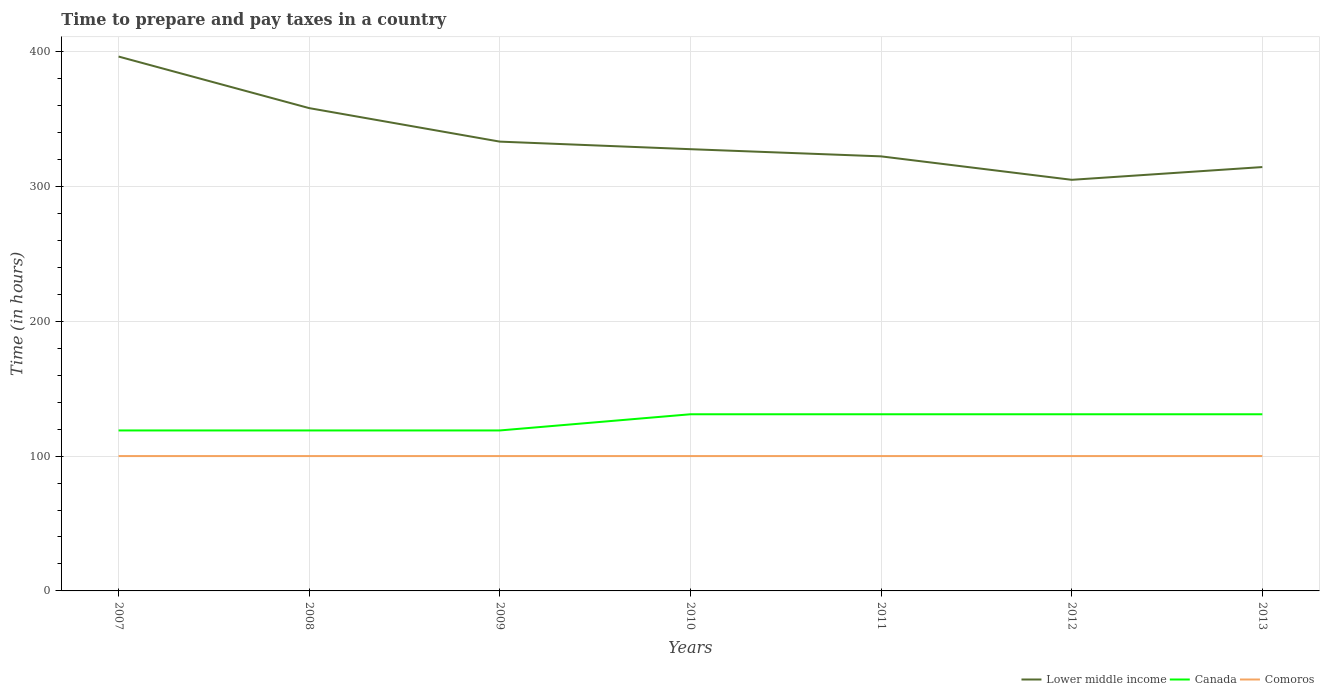Does the line corresponding to Lower middle income intersect with the line corresponding to Comoros?
Ensure brevity in your answer.  No. Across all years, what is the maximum number of hours required to prepare and pay taxes in Comoros?
Provide a short and direct response. 100. In which year was the number of hours required to prepare and pay taxes in Comoros maximum?
Make the answer very short. 2007. What is the difference between the highest and the second highest number of hours required to prepare and pay taxes in Canada?
Ensure brevity in your answer.  12. What is the difference between the highest and the lowest number of hours required to prepare and pay taxes in Canada?
Offer a terse response. 4. Is the number of hours required to prepare and pay taxes in Comoros strictly greater than the number of hours required to prepare and pay taxes in Lower middle income over the years?
Your answer should be compact. Yes. How many lines are there?
Your answer should be very brief. 3. How many years are there in the graph?
Give a very brief answer. 7. How many legend labels are there?
Offer a terse response. 3. How are the legend labels stacked?
Your answer should be compact. Horizontal. What is the title of the graph?
Make the answer very short. Time to prepare and pay taxes in a country. What is the label or title of the Y-axis?
Your answer should be compact. Time (in hours). What is the Time (in hours) in Lower middle income in 2007?
Offer a terse response. 396.26. What is the Time (in hours) of Canada in 2007?
Keep it short and to the point. 119. What is the Time (in hours) of Comoros in 2007?
Provide a succinct answer. 100. What is the Time (in hours) of Lower middle income in 2008?
Provide a succinct answer. 358.02. What is the Time (in hours) of Canada in 2008?
Offer a very short reply. 119. What is the Time (in hours) of Comoros in 2008?
Provide a short and direct response. 100. What is the Time (in hours) in Lower middle income in 2009?
Provide a short and direct response. 333.17. What is the Time (in hours) in Canada in 2009?
Make the answer very short. 119. What is the Time (in hours) of Comoros in 2009?
Ensure brevity in your answer.  100. What is the Time (in hours) of Lower middle income in 2010?
Offer a terse response. 327.56. What is the Time (in hours) in Canada in 2010?
Offer a terse response. 131. What is the Time (in hours) in Lower middle income in 2011?
Your response must be concise. 322.24. What is the Time (in hours) of Canada in 2011?
Your answer should be compact. 131. What is the Time (in hours) in Lower middle income in 2012?
Make the answer very short. 304.86. What is the Time (in hours) of Canada in 2012?
Provide a short and direct response. 131. What is the Time (in hours) of Lower middle income in 2013?
Your answer should be very brief. 314.31. What is the Time (in hours) of Canada in 2013?
Provide a short and direct response. 131. What is the Time (in hours) in Comoros in 2013?
Keep it short and to the point. 100. Across all years, what is the maximum Time (in hours) in Lower middle income?
Your answer should be compact. 396.26. Across all years, what is the maximum Time (in hours) of Canada?
Give a very brief answer. 131. Across all years, what is the minimum Time (in hours) of Lower middle income?
Your response must be concise. 304.86. Across all years, what is the minimum Time (in hours) of Canada?
Your response must be concise. 119. What is the total Time (in hours) in Lower middle income in the graph?
Provide a short and direct response. 2356.43. What is the total Time (in hours) of Canada in the graph?
Give a very brief answer. 881. What is the total Time (in hours) of Comoros in the graph?
Offer a terse response. 700. What is the difference between the Time (in hours) of Lower middle income in 2007 and that in 2008?
Keep it short and to the point. 38.25. What is the difference between the Time (in hours) in Canada in 2007 and that in 2008?
Your response must be concise. 0. What is the difference between the Time (in hours) of Lower middle income in 2007 and that in 2009?
Offer a very short reply. 63.09. What is the difference between the Time (in hours) in Lower middle income in 2007 and that in 2010?
Your response must be concise. 68.7. What is the difference between the Time (in hours) of Canada in 2007 and that in 2010?
Offer a very short reply. -12. What is the difference between the Time (in hours) in Comoros in 2007 and that in 2010?
Your answer should be compact. 0. What is the difference between the Time (in hours) of Lower middle income in 2007 and that in 2011?
Your answer should be compact. 74.02. What is the difference between the Time (in hours) in Canada in 2007 and that in 2011?
Make the answer very short. -12. What is the difference between the Time (in hours) of Lower middle income in 2007 and that in 2012?
Make the answer very short. 91.4. What is the difference between the Time (in hours) of Canada in 2007 and that in 2012?
Your answer should be very brief. -12. What is the difference between the Time (in hours) of Comoros in 2007 and that in 2012?
Offer a very short reply. 0. What is the difference between the Time (in hours) of Lower middle income in 2007 and that in 2013?
Give a very brief answer. 81.95. What is the difference between the Time (in hours) of Canada in 2007 and that in 2013?
Your answer should be compact. -12. What is the difference between the Time (in hours) of Comoros in 2007 and that in 2013?
Your response must be concise. 0. What is the difference between the Time (in hours) of Lower middle income in 2008 and that in 2009?
Provide a succinct answer. 24.84. What is the difference between the Time (in hours) of Lower middle income in 2008 and that in 2010?
Provide a succinct answer. 30.45. What is the difference between the Time (in hours) in Comoros in 2008 and that in 2010?
Your response must be concise. 0. What is the difference between the Time (in hours) in Lower middle income in 2008 and that in 2011?
Provide a succinct answer. 35.77. What is the difference between the Time (in hours) of Canada in 2008 and that in 2011?
Make the answer very short. -12. What is the difference between the Time (in hours) in Lower middle income in 2008 and that in 2012?
Provide a short and direct response. 53.16. What is the difference between the Time (in hours) of Lower middle income in 2008 and that in 2013?
Give a very brief answer. 43.7. What is the difference between the Time (in hours) of Lower middle income in 2009 and that in 2010?
Provide a short and direct response. 5.61. What is the difference between the Time (in hours) of Canada in 2009 and that in 2010?
Provide a succinct answer. -12. What is the difference between the Time (in hours) of Lower middle income in 2009 and that in 2011?
Your response must be concise. 10.93. What is the difference between the Time (in hours) of Canada in 2009 and that in 2011?
Your answer should be very brief. -12. What is the difference between the Time (in hours) in Lower middle income in 2009 and that in 2012?
Provide a succinct answer. 28.31. What is the difference between the Time (in hours) of Comoros in 2009 and that in 2012?
Ensure brevity in your answer.  0. What is the difference between the Time (in hours) of Lower middle income in 2009 and that in 2013?
Provide a short and direct response. 18.86. What is the difference between the Time (in hours) of Canada in 2009 and that in 2013?
Provide a short and direct response. -12. What is the difference between the Time (in hours) of Comoros in 2009 and that in 2013?
Your answer should be very brief. 0. What is the difference between the Time (in hours) of Lower middle income in 2010 and that in 2011?
Keep it short and to the point. 5.32. What is the difference between the Time (in hours) in Canada in 2010 and that in 2011?
Provide a succinct answer. 0. What is the difference between the Time (in hours) in Lower middle income in 2010 and that in 2012?
Provide a succinct answer. 22.7. What is the difference between the Time (in hours) in Comoros in 2010 and that in 2012?
Keep it short and to the point. 0. What is the difference between the Time (in hours) of Lower middle income in 2010 and that in 2013?
Ensure brevity in your answer.  13.25. What is the difference between the Time (in hours) of Lower middle income in 2011 and that in 2012?
Provide a succinct answer. 17.39. What is the difference between the Time (in hours) of Canada in 2011 and that in 2012?
Make the answer very short. 0. What is the difference between the Time (in hours) of Lower middle income in 2011 and that in 2013?
Offer a very short reply. 7.93. What is the difference between the Time (in hours) in Comoros in 2011 and that in 2013?
Ensure brevity in your answer.  0. What is the difference between the Time (in hours) in Lower middle income in 2012 and that in 2013?
Give a very brief answer. -9.45. What is the difference between the Time (in hours) of Lower middle income in 2007 and the Time (in hours) of Canada in 2008?
Make the answer very short. 277.26. What is the difference between the Time (in hours) in Lower middle income in 2007 and the Time (in hours) in Comoros in 2008?
Keep it short and to the point. 296.26. What is the difference between the Time (in hours) of Lower middle income in 2007 and the Time (in hours) of Canada in 2009?
Your answer should be very brief. 277.26. What is the difference between the Time (in hours) of Lower middle income in 2007 and the Time (in hours) of Comoros in 2009?
Offer a very short reply. 296.26. What is the difference between the Time (in hours) in Canada in 2007 and the Time (in hours) in Comoros in 2009?
Offer a terse response. 19. What is the difference between the Time (in hours) in Lower middle income in 2007 and the Time (in hours) in Canada in 2010?
Your answer should be very brief. 265.26. What is the difference between the Time (in hours) in Lower middle income in 2007 and the Time (in hours) in Comoros in 2010?
Make the answer very short. 296.26. What is the difference between the Time (in hours) of Canada in 2007 and the Time (in hours) of Comoros in 2010?
Keep it short and to the point. 19. What is the difference between the Time (in hours) of Lower middle income in 2007 and the Time (in hours) of Canada in 2011?
Your answer should be very brief. 265.26. What is the difference between the Time (in hours) in Lower middle income in 2007 and the Time (in hours) in Comoros in 2011?
Offer a very short reply. 296.26. What is the difference between the Time (in hours) in Lower middle income in 2007 and the Time (in hours) in Canada in 2012?
Provide a succinct answer. 265.26. What is the difference between the Time (in hours) in Lower middle income in 2007 and the Time (in hours) in Comoros in 2012?
Keep it short and to the point. 296.26. What is the difference between the Time (in hours) of Lower middle income in 2007 and the Time (in hours) of Canada in 2013?
Ensure brevity in your answer.  265.26. What is the difference between the Time (in hours) in Lower middle income in 2007 and the Time (in hours) in Comoros in 2013?
Offer a terse response. 296.26. What is the difference between the Time (in hours) of Lower middle income in 2008 and the Time (in hours) of Canada in 2009?
Give a very brief answer. 239.02. What is the difference between the Time (in hours) of Lower middle income in 2008 and the Time (in hours) of Comoros in 2009?
Your response must be concise. 258.02. What is the difference between the Time (in hours) in Canada in 2008 and the Time (in hours) in Comoros in 2009?
Your answer should be very brief. 19. What is the difference between the Time (in hours) of Lower middle income in 2008 and the Time (in hours) of Canada in 2010?
Provide a short and direct response. 227.02. What is the difference between the Time (in hours) of Lower middle income in 2008 and the Time (in hours) of Comoros in 2010?
Make the answer very short. 258.02. What is the difference between the Time (in hours) in Lower middle income in 2008 and the Time (in hours) in Canada in 2011?
Provide a succinct answer. 227.02. What is the difference between the Time (in hours) of Lower middle income in 2008 and the Time (in hours) of Comoros in 2011?
Keep it short and to the point. 258.02. What is the difference between the Time (in hours) in Canada in 2008 and the Time (in hours) in Comoros in 2011?
Your response must be concise. 19. What is the difference between the Time (in hours) in Lower middle income in 2008 and the Time (in hours) in Canada in 2012?
Keep it short and to the point. 227.02. What is the difference between the Time (in hours) of Lower middle income in 2008 and the Time (in hours) of Comoros in 2012?
Your answer should be very brief. 258.02. What is the difference between the Time (in hours) in Lower middle income in 2008 and the Time (in hours) in Canada in 2013?
Your answer should be compact. 227.02. What is the difference between the Time (in hours) of Lower middle income in 2008 and the Time (in hours) of Comoros in 2013?
Keep it short and to the point. 258.02. What is the difference between the Time (in hours) of Lower middle income in 2009 and the Time (in hours) of Canada in 2010?
Offer a terse response. 202.17. What is the difference between the Time (in hours) of Lower middle income in 2009 and the Time (in hours) of Comoros in 2010?
Your response must be concise. 233.17. What is the difference between the Time (in hours) in Canada in 2009 and the Time (in hours) in Comoros in 2010?
Your response must be concise. 19. What is the difference between the Time (in hours) of Lower middle income in 2009 and the Time (in hours) of Canada in 2011?
Keep it short and to the point. 202.17. What is the difference between the Time (in hours) in Lower middle income in 2009 and the Time (in hours) in Comoros in 2011?
Make the answer very short. 233.17. What is the difference between the Time (in hours) in Lower middle income in 2009 and the Time (in hours) in Canada in 2012?
Give a very brief answer. 202.17. What is the difference between the Time (in hours) of Lower middle income in 2009 and the Time (in hours) of Comoros in 2012?
Your answer should be very brief. 233.17. What is the difference between the Time (in hours) of Lower middle income in 2009 and the Time (in hours) of Canada in 2013?
Your response must be concise. 202.17. What is the difference between the Time (in hours) in Lower middle income in 2009 and the Time (in hours) in Comoros in 2013?
Your response must be concise. 233.17. What is the difference between the Time (in hours) of Canada in 2009 and the Time (in hours) of Comoros in 2013?
Offer a very short reply. 19. What is the difference between the Time (in hours) in Lower middle income in 2010 and the Time (in hours) in Canada in 2011?
Offer a terse response. 196.56. What is the difference between the Time (in hours) of Lower middle income in 2010 and the Time (in hours) of Comoros in 2011?
Make the answer very short. 227.56. What is the difference between the Time (in hours) in Canada in 2010 and the Time (in hours) in Comoros in 2011?
Provide a short and direct response. 31. What is the difference between the Time (in hours) in Lower middle income in 2010 and the Time (in hours) in Canada in 2012?
Your answer should be very brief. 196.56. What is the difference between the Time (in hours) in Lower middle income in 2010 and the Time (in hours) in Comoros in 2012?
Your answer should be very brief. 227.56. What is the difference between the Time (in hours) of Canada in 2010 and the Time (in hours) of Comoros in 2012?
Provide a succinct answer. 31. What is the difference between the Time (in hours) in Lower middle income in 2010 and the Time (in hours) in Canada in 2013?
Give a very brief answer. 196.56. What is the difference between the Time (in hours) of Lower middle income in 2010 and the Time (in hours) of Comoros in 2013?
Your answer should be compact. 227.56. What is the difference between the Time (in hours) in Lower middle income in 2011 and the Time (in hours) in Canada in 2012?
Offer a terse response. 191.24. What is the difference between the Time (in hours) in Lower middle income in 2011 and the Time (in hours) in Comoros in 2012?
Offer a terse response. 222.24. What is the difference between the Time (in hours) in Canada in 2011 and the Time (in hours) in Comoros in 2012?
Keep it short and to the point. 31. What is the difference between the Time (in hours) in Lower middle income in 2011 and the Time (in hours) in Canada in 2013?
Your answer should be compact. 191.24. What is the difference between the Time (in hours) in Lower middle income in 2011 and the Time (in hours) in Comoros in 2013?
Keep it short and to the point. 222.24. What is the difference between the Time (in hours) in Canada in 2011 and the Time (in hours) in Comoros in 2013?
Offer a terse response. 31. What is the difference between the Time (in hours) in Lower middle income in 2012 and the Time (in hours) in Canada in 2013?
Offer a very short reply. 173.86. What is the difference between the Time (in hours) of Lower middle income in 2012 and the Time (in hours) of Comoros in 2013?
Make the answer very short. 204.86. What is the difference between the Time (in hours) in Canada in 2012 and the Time (in hours) in Comoros in 2013?
Keep it short and to the point. 31. What is the average Time (in hours) in Lower middle income per year?
Make the answer very short. 336.63. What is the average Time (in hours) of Canada per year?
Provide a short and direct response. 125.86. In the year 2007, what is the difference between the Time (in hours) of Lower middle income and Time (in hours) of Canada?
Provide a succinct answer. 277.26. In the year 2007, what is the difference between the Time (in hours) of Lower middle income and Time (in hours) of Comoros?
Your answer should be very brief. 296.26. In the year 2008, what is the difference between the Time (in hours) of Lower middle income and Time (in hours) of Canada?
Ensure brevity in your answer.  239.02. In the year 2008, what is the difference between the Time (in hours) of Lower middle income and Time (in hours) of Comoros?
Make the answer very short. 258.02. In the year 2009, what is the difference between the Time (in hours) of Lower middle income and Time (in hours) of Canada?
Your response must be concise. 214.17. In the year 2009, what is the difference between the Time (in hours) in Lower middle income and Time (in hours) in Comoros?
Ensure brevity in your answer.  233.17. In the year 2009, what is the difference between the Time (in hours) in Canada and Time (in hours) in Comoros?
Provide a short and direct response. 19. In the year 2010, what is the difference between the Time (in hours) in Lower middle income and Time (in hours) in Canada?
Keep it short and to the point. 196.56. In the year 2010, what is the difference between the Time (in hours) in Lower middle income and Time (in hours) in Comoros?
Provide a short and direct response. 227.56. In the year 2011, what is the difference between the Time (in hours) in Lower middle income and Time (in hours) in Canada?
Your answer should be compact. 191.24. In the year 2011, what is the difference between the Time (in hours) of Lower middle income and Time (in hours) of Comoros?
Provide a succinct answer. 222.24. In the year 2012, what is the difference between the Time (in hours) of Lower middle income and Time (in hours) of Canada?
Provide a succinct answer. 173.86. In the year 2012, what is the difference between the Time (in hours) of Lower middle income and Time (in hours) of Comoros?
Provide a short and direct response. 204.86. In the year 2013, what is the difference between the Time (in hours) of Lower middle income and Time (in hours) of Canada?
Your answer should be compact. 183.31. In the year 2013, what is the difference between the Time (in hours) of Lower middle income and Time (in hours) of Comoros?
Provide a succinct answer. 214.31. What is the ratio of the Time (in hours) in Lower middle income in 2007 to that in 2008?
Provide a short and direct response. 1.11. What is the ratio of the Time (in hours) of Canada in 2007 to that in 2008?
Your answer should be compact. 1. What is the ratio of the Time (in hours) in Lower middle income in 2007 to that in 2009?
Provide a succinct answer. 1.19. What is the ratio of the Time (in hours) in Lower middle income in 2007 to that in 2010?
Your answer should be compact. 1.21. What is the ratio of the Time (in hours) in Canada in 2007 to that in 2010?
Ensure brevity in your answer.  0.91. What is the ratio of the Time (in hours) of Lower middle income in 2007 to that in 2011?
Your answer should be compact. 1.23. What is the ratio of the Time (in hours) of Canada in 2007 to that in 2011?
Your response must be concise. 0.91. What is the ratio of the Time (in hours) of Lower middle income in 2007 to that in 2012?
Your answer should be compact. 1.3. What is the ratio of the Time (in hours) in Canada in 2007 to that in 2012?
Provide a succinct answer. 0.91. What is the ratio of the Time (in hours) of Comoros in 2007 to that in 2012?
Your answer should be very brief. 1. What is the ratio of the Time (in hours) in Lower middle income in 2007 to that in 2013?
Your answer should be compact. 1.26. What is the ratio of the Time (in hours) of Canada in 2007 to that in 2013?
Make the answer very short. 0.91. What is the ratio of the Time (in hours) in Lower middle income in 2008 to that in 2009?
Provide a short and direct response. 1.07. What is the ratio of the Time (in hours) in Canada in 2008 to that in 2009?
Offer a terse response. 1. What is the ratio of the Time (in hours) in Lower middle income in 2008 to that in 2010?
Your response must be concise. 1.09. What is the ratio of the Time (in hours) in Canada in 2008 to that in 2010?
Offer a very short reply. 0.91. What is the ratio of the Time (in hours) in Comoros in 2008 to that in 2010?
Offer a terse response. 1. What is the ratio of the Time (in hours) in Lower middle income in 2008 to that in 2011?
Make the answer very short. 1.11. What is the ratio of the Time (in hours) in Canada in 2008 to that in 2011?
Offer a terse response. 0.91. What is the ratio of the Time (in hours) of Comoros in 2008 to that in 2011?
Your response must be concise. 1. What is the ratio of the Time (in hours) in Lower middle income in 2008 to that in 2012?
Give a very brief answer. 1.17. What is the ratio of the Time (in hours) of Canada in 2008 to that in 2012?
Your answer should be very brief. 0.91. What is the ratio of the Time (in hours) in Lower middle income in 2008 to that in 2013?
Ensure brevity in your answer.  1.14. What is the ratio of the Time (in hours) of Canada in 2008 to that in 2013?
Give a very brief answer. 0.91. What is the ratio of the Time (in hours) in Comoros in 2008 to that in 2013?
Give a very brief answer. 1. What is the ratio of the Time (in hours) of Lower middle income in 2009 to that in 2010?
Your response must be concise. 1.02. What is the ratio of the Time (in hours) of Canada in 2009 to that in 2010?
Keep it short and to the point. 0.91. What is the ratio of the Time (in hours) of Comoros in 2009 to that in 2010?
Provide a succinct answer. 1. What is the ratio of the Time (in hours) of Lower middle income in 2009 to that in 2011?
Provide a short and direct response. 1.03. What is the ratio of the Time (in hours) of Canada in 2009 to that in 2011?
Your answer should be compact. 0.91. What is the ratio of the Time (in hours) of Comoros in 2009 to that in 2011?
Your answer should be very brief. 1. What is the ratio of the Time (in hours) of Lower middle income in 2009 to that in 2012?
Keep it short and to the point. 1.09. What is the ratio of the Time (in hours) in Canada in 2009 to that in 2012?
Ensure brevity in your answer.  0.91. What is the ratio of the Time (in hours) of Lower middle income in 2009 to that in 2013?
Make the answer very short. 1.06. What is the ratio of the Time (in hours) in Canada in 2009 to that in 2013?
Make the answer very short. 0.91. What is the ratio of the Time (in hours) of Comoros in 2009 to that in 2013?
Your response must be concise. 1. What is the ratio of the Time (in hours) in Lower middle income in 2010 to that in 2011?
Provide a short and direct response. 1.02. What is the ratio of the Time (in hours) of Comoros in 2010 to that in 2011?
Make the answer very short. 1. What is the ratio of the Time (in hours) of Lower middle income in 2010 to that in 2012?
Make the answer very short. 1.07. What is the ratio of the Time (in hours) of Canada in 2010 to that in 2012?
Make the answer very short. 1. What is the ratio of the Time (in hours) of Lower middle income in 2010 to that in 2013?
Your answer should be very brief. 1.04. What is the ratio of the Time (in hours) of Lower middle income in 2011 to that in 2012?
Provide a succinct answer. 1.06. What is the ratio of the Time (in hours) of Comoros in 2011 to that in 2012?
Provide a short and direct response. 1. What is the ratio of the Time (in hours) in Lower middle income in 2011 to that in 2013?
Give a very brief answer. 1.03. What is the ratio of the Time (in hours) in Canada in 2011 to that in 2013?
Make the answer very short. 1. What is the ratio of the Time (in hours) of Comoros in 2011 to that in 2013?
Your response must be concise. 1. What is the ratio of the Time (in hours) in Lower middle income in 2012 to that in 2013?
Provide a short and direct response. 0.97. What is the ratio of the Time (in hours) of Comoros in 2012 to that in 2013?
Your answer should be very brief. 1. What is the difference between the highest and the second highest Time (in hours) in Lower middle income?
Keep it short and to the point. 38.25. What is the difference between the highest and the second highest Time (in hours) in Canada?
Keep it short and to the point. 0. What is the difference between the highest and the second highest Time (in hours) in Comoros?
Provide a succinct answer. 0. What is the difference between the highest and the lowest Time (in hours) in Lower middle income?
Provide a short and direct response. 91.4. What is the difference between the highest and the lowest Time (in hours) of Canada?
Your answer should be compact. 12. 